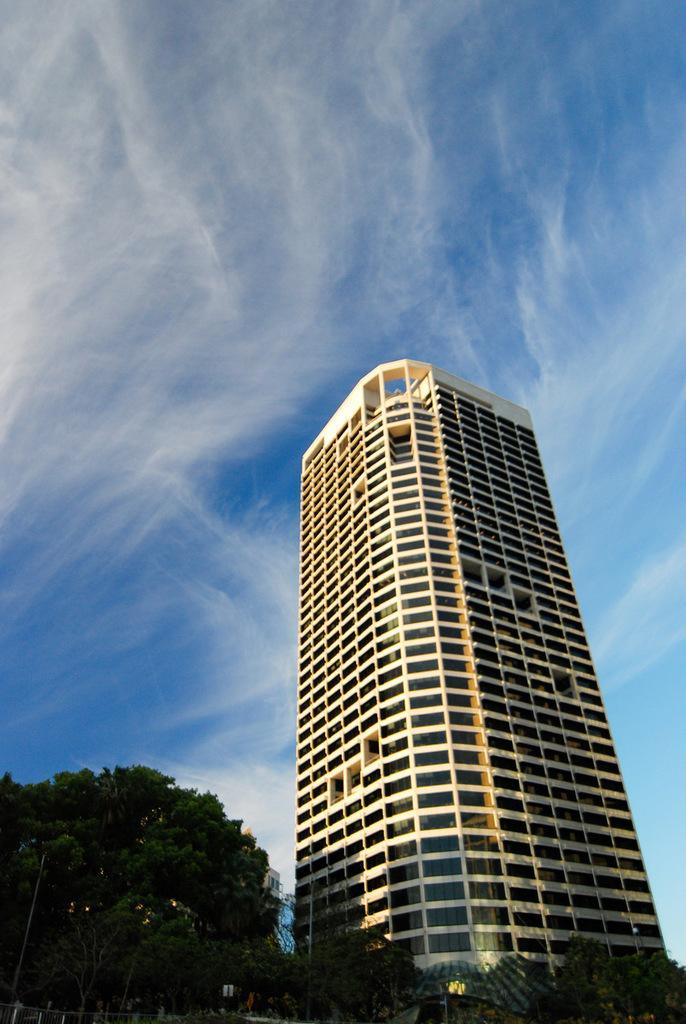Describe this image in one or two sentences. In this image I see a building over here and I see number of trees and I see the sky in the background. 